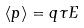Convert formula to latex. <formula><loc_0><loc_0><loc_500><loc_500>\langle p \rangle = q \tau E</formula> 